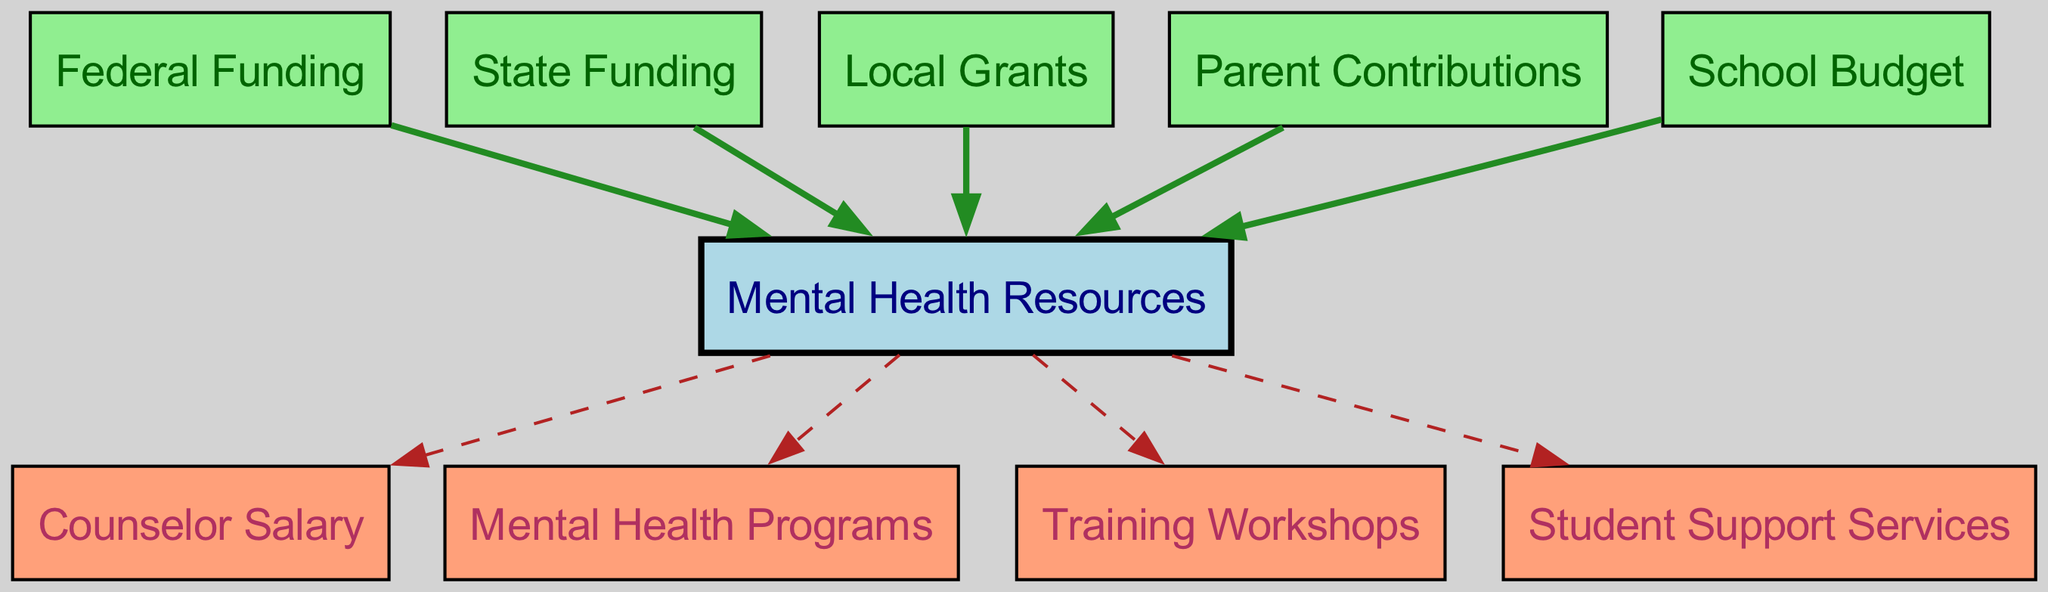What are the funding sources for mental health resources? The directed graph shows five funding sources leading to the mental health resources node: federal funding, state funding, local grants, parent contributions, and school budget. These sources are directly connected to the mental health resources node, indicating their role in resource allocation.
Answer: federal funding, state funding, local grants, parent contributions, school budget How many total nodes are in the diagram? To determine the total number of nodes, count all the unique entries in the 'nodes' array of the data. There are 10 nodes, including the mental health resources and various funding sources and expenditures.
Answer: 10 Which node is connected to the counselor salary? The counselor salary node is connected to the mental health resources node. This is indicated by a directed edge from the mental health resources node to the counselor salary node in the directed graph.
Answer: mental health resources What is the relationship between local grants and mental health resources? The local grants are a funding source that contributes to mental health resources as indicated by a directed edge from the local grants node to the mental health resources node. This signifies that local grants are part of the financial support for mental health initiatives.
Answer: funding source How many edges connect to the mental health resources node? By analyzing the edges, count how many directed edges lead to the mental health resources node. There are five distinct funding sources connected to it.
Answer: 5 Which expenditures are funded by mental health resources? The expenditures funded by mental health resources include counselor salary, mental health programs, training workshops, and student support services. Each of these nodes has a directed edge coming from the mental health resources node, indicating their dependence on it for funding.
Answer: counselor salary, mental health programs, training workshops, student support services What type of node is the school budget? The school budget node is categorized under funding sources as it is connected to the mental health resources node, which shows that the budget is used to support mental health initiatives in the school. It is shown in green, indicating its role as a funding source.
Answer: funding source Which expenditure has a direct contribution from parent contributions? Parent contributions indirectly fund mental health resources, which then fund various expenditures. However, there is no direct connection from parent contributions to specific expenditures, only to mental health resources.
Answer: none How many directed edges are in the diagram? Count the number of unique directed connections in the 'edges' array to find the total number of directed edges. There are 9 edges in total connecting various nodes in the graph.
Answer: 9 